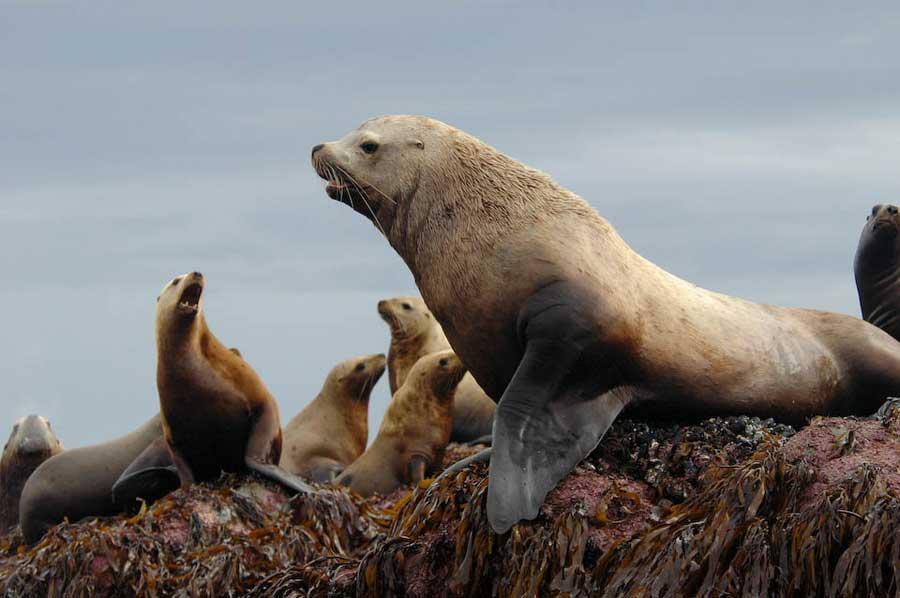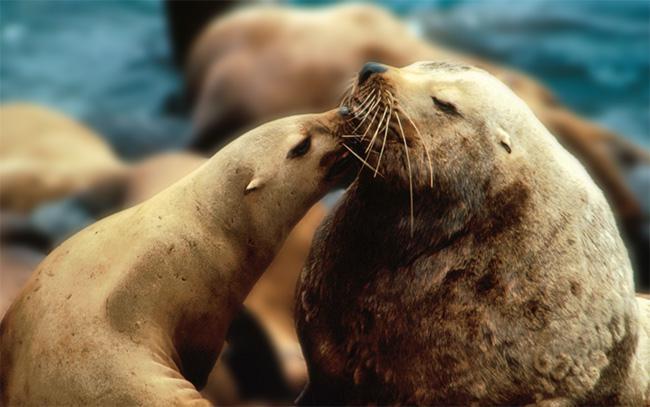The first image is the image on the left, the second image is the image on the right. For the images displayed, is the sentence "At least one of the images shows only one sea lion." factually correct? Answer yes or no. No. 